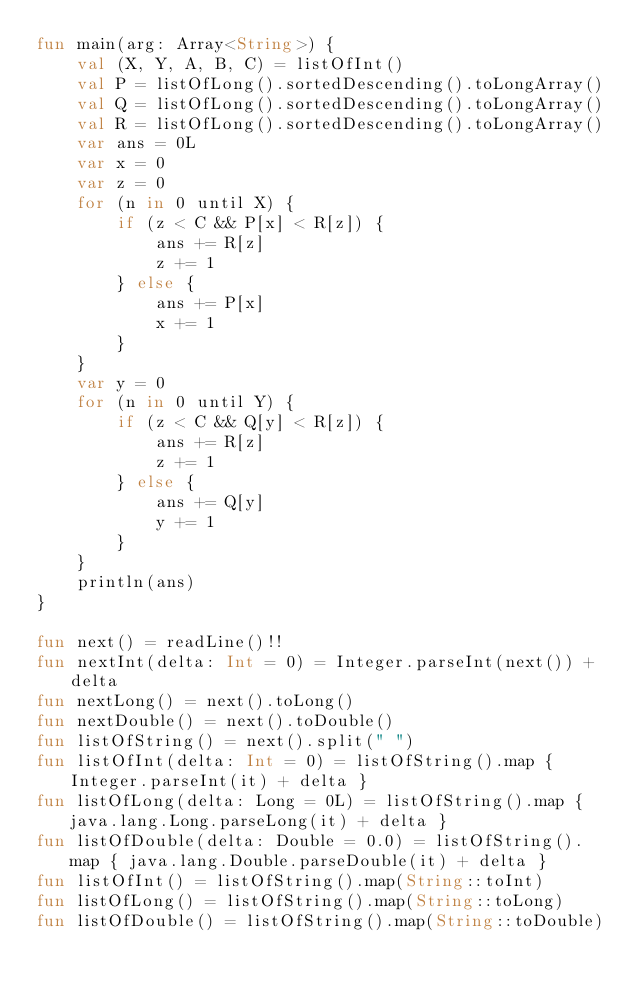<code> <loc_0><loc_0><loc_500><loc_500><_Kotlin_>fun main(arg: Array<String>) {
    val (X, Y, A, B, C) = listOfInt()
    val P = listOfLong().sortedDescending().toLongArray()
    val Q = listOfLong().sortedDescending().toLongArray()
    val R = listOfLong().sortedDescending().toLongArray()
    var ans = 0L
    var x = 0
    var z = 0
    for (n in 0 until X) {
        if (z < C && P[x] < R[z]) {
            ans += R[z]
            z += 1
        } else {
            ans += P[x]
            x += 1
        }
    }
    var y = 0
    for (n in 0 until Y) {
        if (z < C && Q[y] < R[z]) {
            ans += R[z]
            z += 1
        } else {
            ans += Q[y]
            y += 1
        }
    }
    println(ans)
}

fun next() = readLine()!!
fun nextInt(delta: Int = 0) = Integer.parseInt(next()) + delta
fun nextLong() = next().toLong()
fun nextDouble() = next().toDouble()
fun listOfString() = next().split(" ")
fun listOfInt(delta: Int = 0) = listOfString().map { Integer.parseInt(it) + delta }
fun listOfLong(delta: Long = 0L) = listOfString().map { java.lang.Long.parseLong(it) + delta }
fun listOfDouble(delta: Double = 0.0) = listOfString().map { java.lang.Double.parseDouble(it) + delta }
fun listOfInt() = listOfString().map(String::toInt)
fun listOfLong() = listOfString().map(String::toLong)
fun listOfDouble() = listOfString().map(String::toDouble)
</code> 